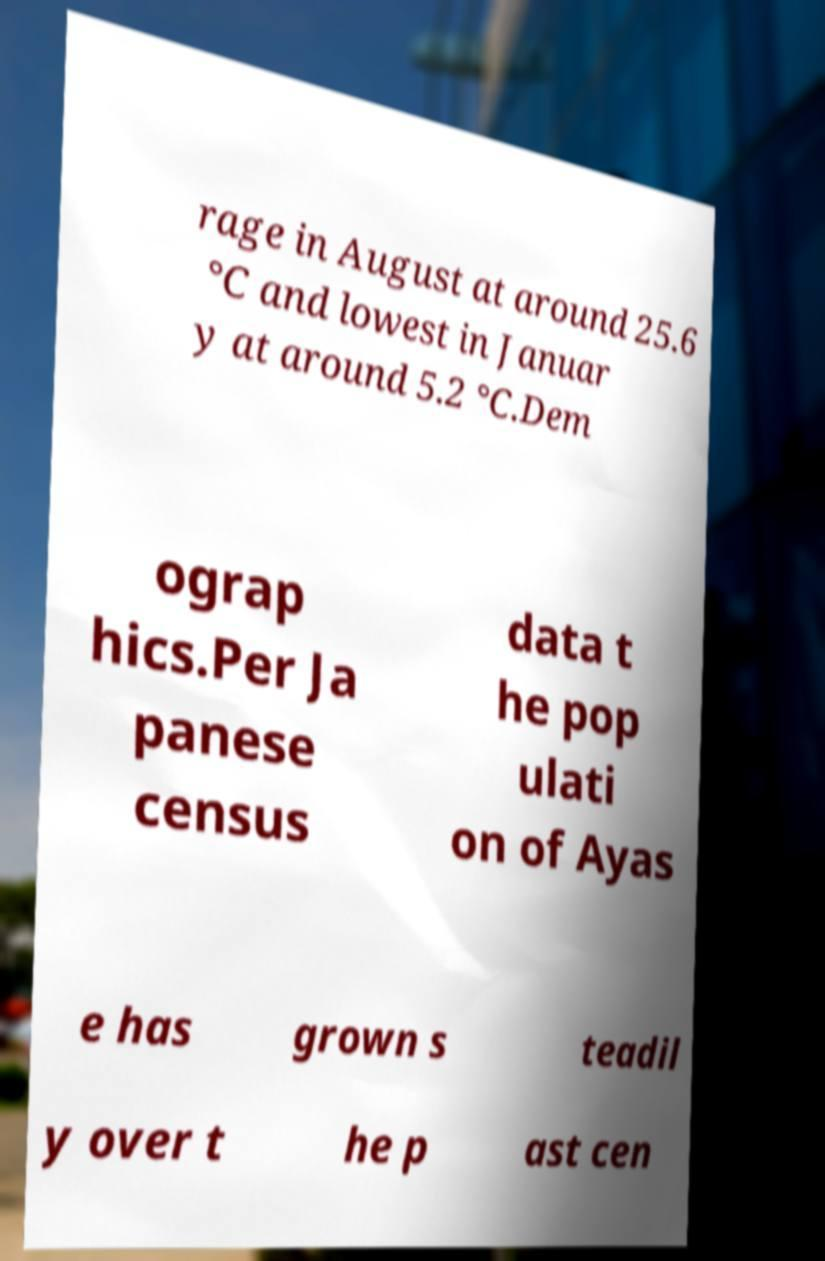Please identify and transcribe the text found in this image. rage in August at around 25.6 °C and lowest in Januar y at around 5.2 °C.Dem ograp hics.Per Ja panese census data t he pop ulati on of Ayas e has grown s teadil y over t he p ast cen 